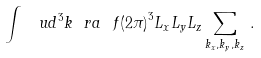<formula> <loc_0><loc_0><loc_500><loc_500>\int \, \ u d ^ { 3 } k \ r a \ f { { ( 2 \pi ) } ^ { 3 } } { L _ { x } L _ { y } L _ { z } } \sum _ { k _ { x } , k _ { y } , k _ { z } } \, .</formula> 